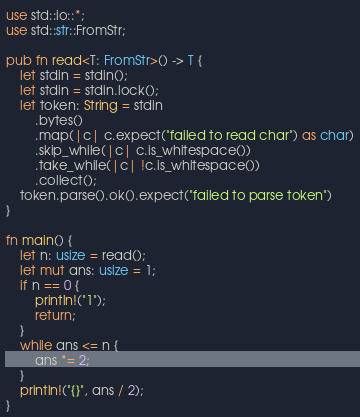<code> <loc_0><loc_0><loc_500><loc_500><_Rust_>use std::io::*;
use std::str::FromStr;

pub fn read<T: FromStr>() -> T {
    let stdin = stdin();
    let stdin = stdin.lock();
    let token: String = stdin
        .bytes()
        .map(|c| c.expect("failed to read char") as char)
        .skip_while(|c| c.is_whitespace())
        .take_while(|c| !c.is_whitespace())
        .collect();
    token.parse().ok().expect("failed to parse token")
}

fn main() {
    let n: usize = read();
    let mut ans: usize = 1;
    if n == 0 {
        println!("1");
        return;
    }
    while ans <= n {
        ans *= 2;
    }
    println!("{}", ans / 2);
}
</code> 